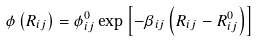Convert formula to latex. <formula><loc_0><loc_0><loc_500><loc_500>\phi \left ( R _ { i j } \right ) = \phi _ { i j } ^ { 0 } \exp \left [ - \beta _ { i j } \left ( R _ { i j } - R _ { i j } ^ { 0 } \right ) \right ]</formula> 